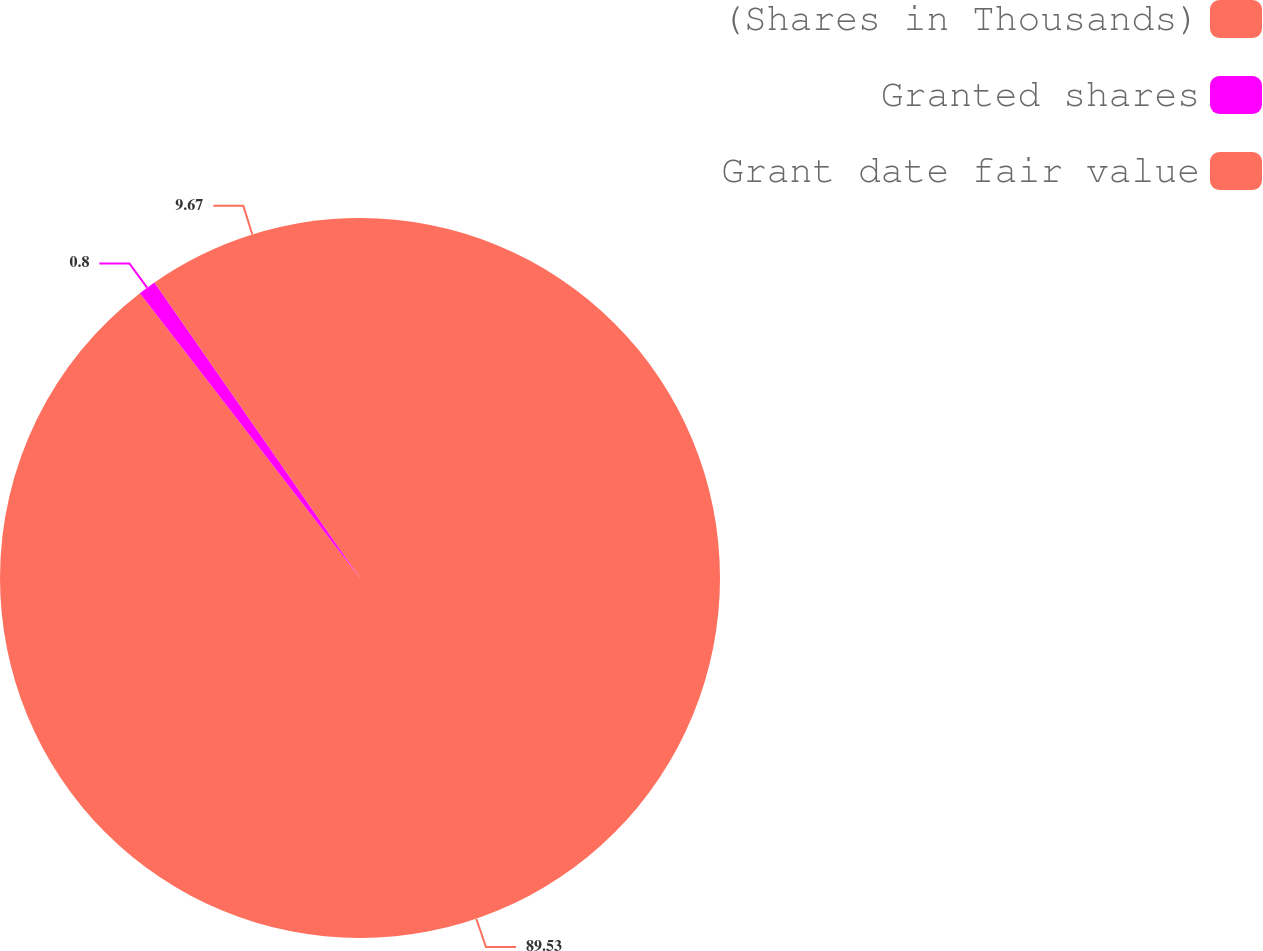Convert chart. <chart><loc_0><loc_0><loc_500><loc_500><pie_chart><fcel>(Shares in Thousands)<fcel>Granted shares<fcel>Grant date fair value<nl><fcel>89.53%<fcel>0.8%<fcel>9.67%<nl></chart> 